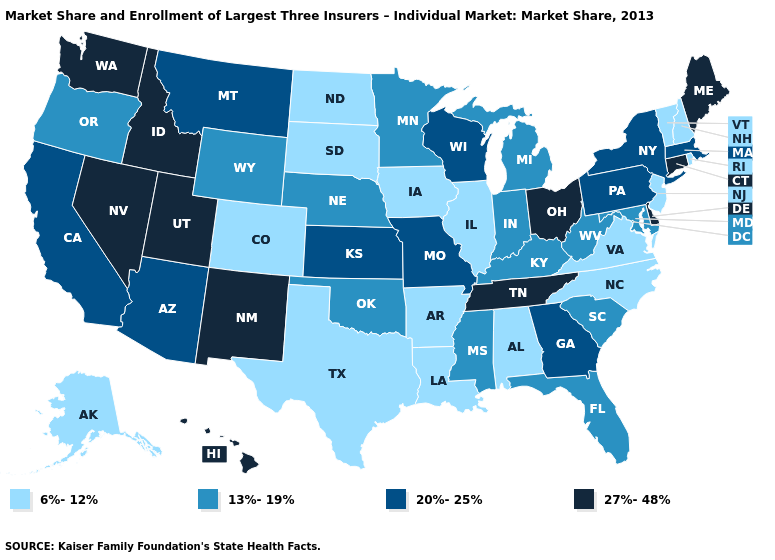What is the highest value in the MidWest ?
Give a very brief answer. 27%-48%. Among the states that border Nebraska , does Iowa have the highest value?
Quick response, please. No. What is the highest value in states that border New York?
Short answer required. 27%-48%. Name the states that have a value in the range 20%-25%?
Write a very short answer. Arizona, California, Georgia, Kansas, Massachusetts, Missouri, Montana, New York, Pennsylvania, Wisconsin. Among the states that border Iowa , does Nebraska have the highest value?
Keep it brief. No. Name the states that have a value in the range 13%-19%?
Write a very short answer. Florida, Indiana, Kentucky, Maryland, Michigan, Minnesota, Mississippi, Nebraska, Oklahoma, Oregon, South Carolina, West Virginia, Wyoming. Does the first symbol in the legend represent the smallest category?
Answer briefly. Yes. Is the legend a continuous bar?
Keep it brief. No. Among the states that border Massachusetts , which have the lowest value?
Be succinct. New Hampshire, Rhode Island, Vermont. Name the states that have a value in the range 20%-25%?
Give a very brief answer. Arizona, California, Georgia, Kansas, Massachusetts, Missouri, Montana, New York, Pennsylvania, Wisconsin. What is the value of Delaware?
Give a very brief answer. 27%-48%. What is the lowest value in the West?
Quick response, please. 6%-12%. Name the states that have a value in the range 6%-12%?
Write a very short answer. Alabama, Alaska, Arkansas, Colorado, Illinois, Iowa, Louisiana, New Hampshire, New Jersey, North Carolina, North Dakota, Rhode Island, South Dakota, Texas, Vermont, Virginia. Name the states that have a value in the range 6%-12%?
Write a very short answer. Alabama, Alaska, Arkansas, Colorado, Illinois, Iowa, Louisiana, New Hampshire, New Jersey, North Carolina, North Dakota, Rhode Island, South Dakota, Texas, Vermont, Virginia. 